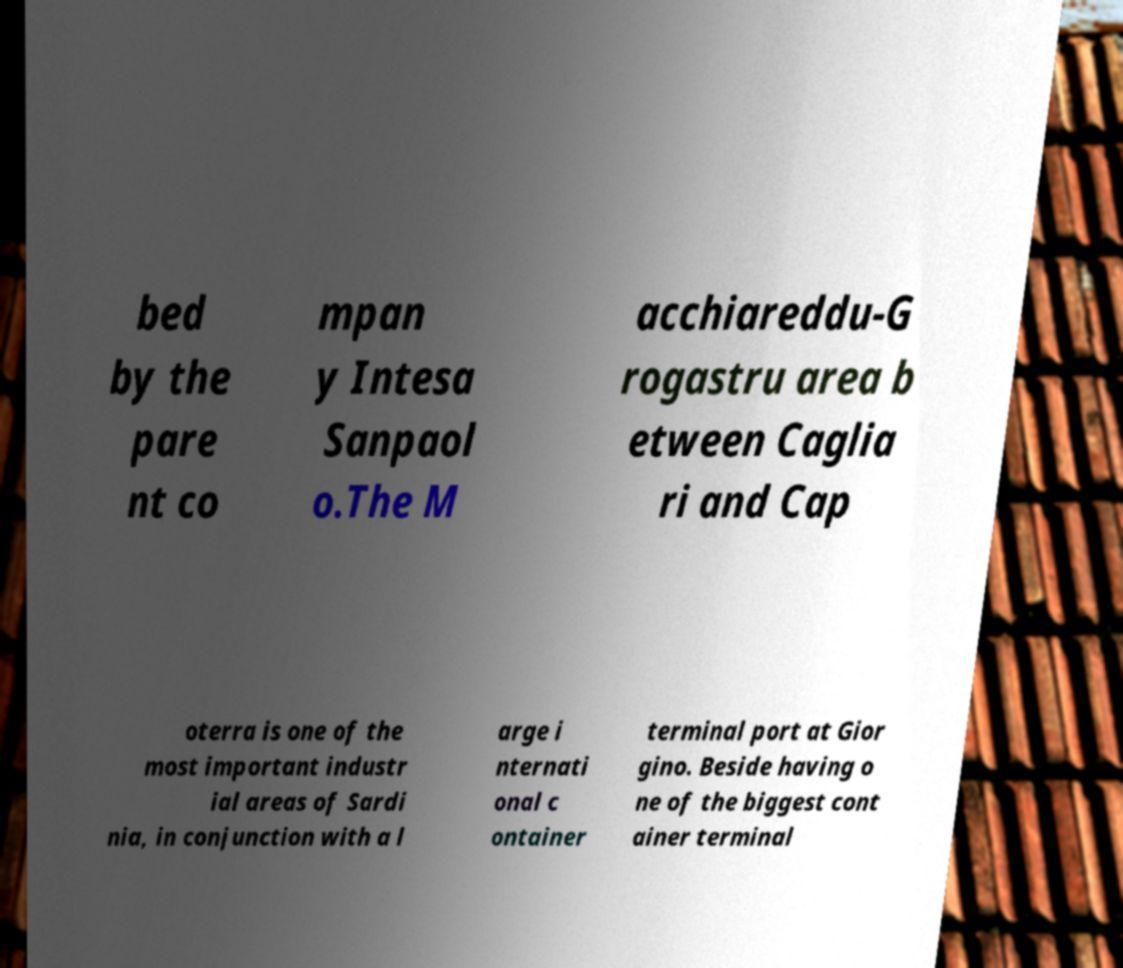What messages or text are displayed in this image? I need them in a readable, typed format. bed by the pare nt co mpan y Intesa Sanpaol o.The M acchiareddu-G rogastru area b etween Caglia ri and Cap oterra is one of the most important industr ial areas of Sardi nia, in conjunction with a l arge i nternati onal c ontainer terminal port at Gior gino. Beside having o ne of the biggest cont ainer terminal 